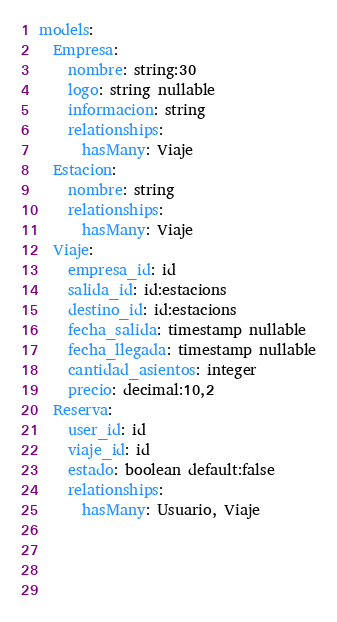Convert code to text. <code><loc_0><loc_0><loc_500><loc_500><_YAML_>models:
  Empresa: 
    nombre: string:30
    logo: string nullable
    informacion: string
    relationships:
      hasMany: Viaje
  Estacion:
    nombre: string
    relationships:
      hasMany: Viaje
  Viaje:
    empresa_id: id
    salida_id: id:estacions
    destino_id: id:estacions 
    fecha_salida: timestamp nullable
    fecha_llegada: timestamp nullable
    cantidad_asientos: integer
    precio: decimal:10,2
  Reserva:
    user_id: id
    viaje_id: id
    estado: boolean default:false
    relationships:
      hasMany: Usuario, Viaje
  
  
    
    
</code> 